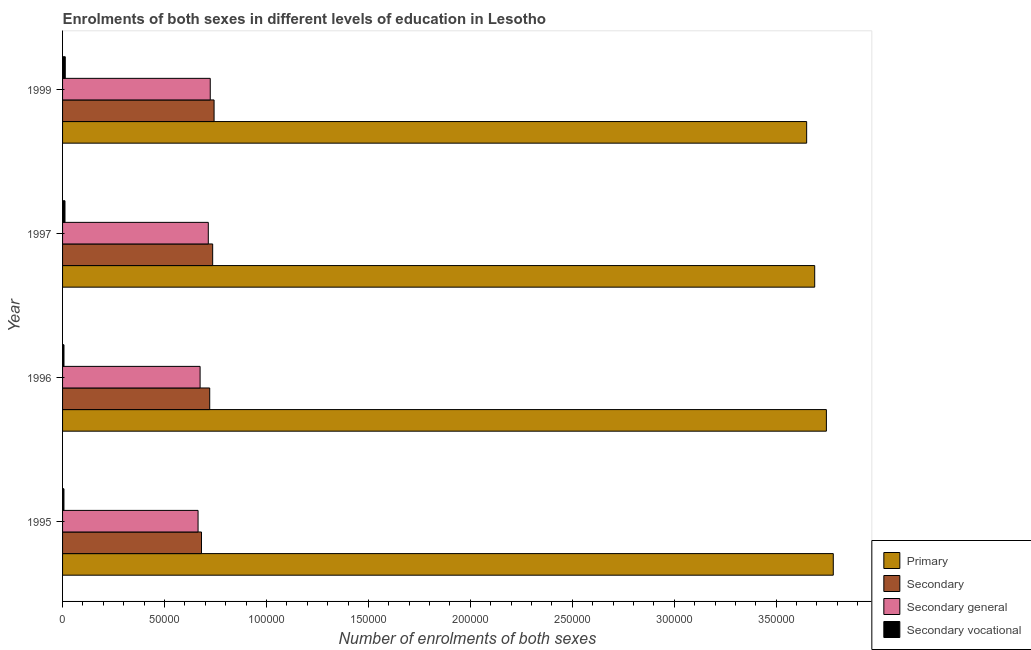How many groups of bars are there?
Give a very brief answer. 4. Are the number of bars per tick equal to the number of legend labels?
Offer a very short reply. Yes. How many bars are there on the 1st tick from the top?
Your answer should be compact. 4. How many bars are there on the 3rd tick from the bottom?
Ensure brevity in your answer.  4. What is the label of the 2nd group of bars from the top?
Offer a terse response. 1997. What is the number of enrolments in secondary general education in 1996?
Give a very brief answer. 6.75e+04. Across all years, what is the maximum number of enrolments in secondary general education?
Your answer should be very brief. 7.24e+04. Across all years, what is the minimum number of enrolments in secondary education?
Your answer should be compact. 6.81e+04. In which year was the number of enrolments in secondary education maximum?
Ensure brevity in your answer.  1999. What is the total number of enrolments in secondary general education in the graph?
Your response must be concise. 2.78e+05. What is the difference between the number of enrolments in secondary vocational education in 1996 and that in 1997?
Give a very brief answer. -488. What is the difference between the number of enrolments in secondary general education in 1995 and the number of enrolments in secondary vocational education in 1999?
Offer a terse response. 6.51e+04. What is the average number of enrolments in secondary general education per year?
Provide a short and direct response. 6.95e+04. In the year 1996, what is the difference between the number of enrolments in secondary vocational education and number of enrolments in primary education?
Provide a succinct answer. -3.74e+05. What is the difference between the highest and the second highest number of enrolments in secondary general education?
Give a very brief answer. 962. What is the difference between the highest and the lowest number of enrolments in secondary vocational education?
Provide a short and direct response. 643. In how many years, is the number of enrolments in primary education greater than the average number of enrolments in primary education taken over all years?
Give a very brief answer. 2. What does the 3rd bar from the top in 1995 represents?
Offer a very short reply. Secondary. What does the 1st bar from the bottom in 1996 represents?
Give a very brief answer. Primary. Is it the case that in every year, the sum of the number of enrolments in primary education and number of enrolments in secondary education is greater than the number of enrolments in secondary general education?
Offer a terse response. Yes. Are all the bars in the graph horizontal?
Your answer should be compact. Yes. How many years are there in the graph?
Ensure brevity in your answer.  4. Are the values on the major ticks of X-axis written in scientific E-notation?
Make the answer very short. No. Does the graph contain any zero values?
Provide a succinct answer. No. Where does the legend appear in the graph?
Your response must be concise. Bottom right. How many legend labels are there?
Make the answer very short. 4. How are the legend labels stacked?
Your response must be concise. Vertical. What is the title of the graph?
Your answer should be compact. Enrolments of both sexes in different levels of education in Lesotho. Does "Interest Payments" appear as one of the legend labels in the graph?
Ensure brevity in your answer.  No. What is the label or title of the X-axis?
Your response must be concise. Number of enrolments of both sexes. What is the label or title of the Y-axis?
Offer a very short reply. Year. What is the Number of enrolments of both sexes of Primary in 1995?
Give a very brief answer. 3.78e+05. What is the Number of enrolments of both sexes in Secondary in 1995?
Provide a short and direct response. 6.81e+04. What is the Number of enrolments of both sexes of Secondary general in 1995?
Offer a very short reply. 6.65e+04. What is the Number of enrolments of both sexes in Secondary vocational in 1995?
Provide a succinct answer. 678. What is the Number of enrolments of both sexes in Primary in 1996?
Provide a short and direct response. 3.75e+05. What is the Number of enrolments of both sexes in Secondary in 1996?
Your answer should be very brief. 7.22e+04. What is the Number of enrolments of both sexes in Secondary general in 1996?
Provide a succinct answer. 6.75e+04. What is the Number of enrolments of both sexes in Secondary vocational in 1996?
Offer a terse response. 695. What is the Number of enrolments of both sexes of Primary in 1997?
Ensure brevity in your answer.  3.69e+05. What is the Number of enrolments of both sexes in Secondary in 1997?
Offer a terse response. 7.36e+04. What is the Number of enrolments of both sexes in Secondary general in 1997?
Your answer should be very brief. 7.15e+04. What is the Number of enrolments of both sexes in Secondary vocational in 1997?
Ensure brevity in your answer.  1183. What is the Number of enrolments of both sexes of Primary in 1999?
Ensure brevity in your answer.  3.65e+05. What is the Number of enrolments of both sexes in Secondary in 1999?
Offer a terse response. 7.43e+04. What is the Number of enrolments of both sexes in Secondary general in 1999?
Give a very brief answer. 7.24e+04. What is the Number of enrolments of both sexes in Secondary vocational in 1999?
Your response must be concise. 1321. Across all years, what is the maximum Number of enrolments of both sexes in Primary?
Your answer should be very brief. 3.78e+05. Across all years, what is the maximum Number of enrolments of both sexes of Secondary?
Make the answer very short. 7.43e+04. Across all years, what is the maximum Number of enrolments of both sexes of Secondary general?
Your response must be concise. 7.24e+04. Across all years, what is the maximum Number of enrolments of both sexes in Secondary vocational?
Offer a terse response. 1321. Across all years, what is the minimum Number of enrolments of both sexes of Primary?
Keep it short and to the point. 3.65e+05. Across all years, what is the minimum Number of enrolments of both sexes of Secondary?
Offer a terse response. 6.81e+04. Across all years, what is the minimum Number of enrolments of both sexes of Secondary general?
Make the answer very short. 6.65e+04. Across all years, what is the minimum Number of enrolments of both sexes in Secondary vocational?
Offer a terse response. 678. What is the total Number of enrolments of both sexes of Primary in the graph?
Offer a very short reply. 1.49e+06. What is the total Number of enrolments of both sexes in Secondary in the graph?
Make the answer very short. 2.88e+05. What is the total Number of enrolments of both sexes in Secondary general in the graph?
Your answer should be very brief. 2.78e+05. What is the total Number of enrolments of both sexes of Secondary vocational in the graph?
Offer a very short reply. 3877. What is the difference between the Number of enrolments of both sexes of Primary in 1995 and that in 1996?
Make the answer very short. 3383. What is the difference between the Number of enrolments of both sexes in Secondary in 1995 and that in 1996?
Keep it short and to the point. -4038. What is the difference between the Number of enrolments of both sexes of Secondary general in 1995 and that in 1996?
Ensure brevity in your answer.  -1000. What is the difference between the Number of enrolments of both sexes of Secondary vocational in 1995 and that in 1996?
Your answer should be compact. -17. What is the difference between the Number of enrolments of both sexes in Primary in 1995 and that in 1997?
Keep it short and to the point. 9116. What is the difference between the Number of enrolments of both sexes of Secondary in 1995 and that in 1997?
Offer a terse response. -5488. What is the difference between the Number of enrolments of both sexes in Secondary general in 1995 and that in 1997?
Keep it short and to the point. -5021. What is the difference between the Number of enrolments of both sexes of Secondary vocational in 1995 and that in 1997?
Keep it short and to the point. -505. What is the difference between the Number of enrolments of both sexes of Primary in 1995 and that in 1999?
Your answer should be very brief. 1.31e+04. What is the difference between the Number of enrolments of both sexes in Secondary in 1995 and that in 1999?
Your answer should be compact. -6181. What is the difference between the Number of enrolments of both sexes in Secondary general in 1995 and that in 1999?
Give a very brief answer. -5983. What is the difference between the Number of enrolments of both sexes in Secondary vocational in 1995 and that in 1999?
Your answer should be compact. -643. What is the difference between the Number of enrolments of both sexes in Primary in 1996 and that in 1997?
Give a very brief answer. 5733. What is the difference between the Number of enrolments of both sexes of Secondary in 1996 and that in 1997?
Keep it short and to the point. -1450. What is the difference between the Number of enrolments of both sexes in Secondary general in 1996 and that in 1997?
Offer a very short reply. -4021. What is the difference between the Number of enrolments of both sexes of Secondary vocational in 1996 and that in 1997?
Provide a succinct answer. -488. What is the difference between the Number of enrolments of both sexes of Primary in 1996 and that in 1999?
Make the answer very short. 9677. What is the difference between the Number of enrolments of both sexes of Secondary in 1996 and that in 1999?
Offer a terse response. -2143. What is the difference between the Number of enrolments of both sexes of Secondary general in 1996 and that in 1999?
Provide a succinct answer. -4983. What is the difference between the Number of enrolments of both sexes of Secondary vocational in 1996 and that in 1999?
Your answer should be compact. -626. What is the difference between the Number of enrolments of both sexes of Primary in 1997 and that in 1999?
Offer a very short reply. 3944. What is the difference between the Number of enrolments of both sexes in Secondary in 1997 and that in 1999?
Your answer should be very brief. -693. What is the difference between the Number of enrolments of both sexes of Secondary general in 1997 and that in 1999?
Ensure brevity in your answer.  -962. What is the difference between the Number of enrolments of both sexes in Secondary vocational in 1997 and that in 1999?
Make the answer very short. -138. What is the difference between the Number of enrolments of both sexes in Primary in 1995 and the Number of enrolments of both sexes in Secondary in 1996?
Give a very brief answer. 3.06e+05. What is the difference between the Number of enrolments of both sexes of Primary in 1995 and the Number of enrolments of both sexes of Secondary general in 1996?
Your answer should be compact. 3.11e+05. What is the difference between the Number of enrolments of both sexes of Primary in 1995 and the Number of enrolments of both sexes of Secondary vocational in 1996?
Provide a short and direct response. 3.77e+05. What is the difference between the Number of enrolments of both sexes of Secondary in 1995 and the Number of enrolments of both sexes of Secondary general in 1996?
Offer a very short reply. 678. What is the difference between the Number of enrolments of both sexes in Secondary in 1995 and the Number of enrolments of both sexes in Secondary vocational in 1996?
Your response must be concise. 6.74e+04. What is the difference between the Number of enrolments of both sexes of Secondary general in 1995 and the Number of enrolments of both sexes of Secondary vocational in 1996?
Keep it short and to the point. 6.58e+04. What is the difference between the Number of enrolments of both sexes in Primary in 1995 and the Number of enrolments of both sexes in Secondary in 1997?
Provide a succinct answer. 3.04e+05. What is the difference between the Number of enrolments of both sexes of Primary in 1995 and the Number of enrolments of both sexes of Secondary general in 1997?
Your response must be concise. 3.07e+05. What is the difference between the Number of enrolments of both sexes of Primary in 1995 and the Number of enrolments of both sexes of Secondary vocational in 1997?
Keep it short and to the point. 3.77e+05. What is the difference between the Number of enrolments of both sexes in Secondary in 1995 and the Number of enrolments of both sexes in Secondary general in 1997?
Provide a succinct answer. -3343. What is the difference between the Number of enrolments of both sexes of Secondary in 1995 and the Number of enrolments of both sexes of Secondary vocational in 1997?
Your answer should be very brief. 6.69e+04. What is the difference between the Number of enrolments of both sexes in Secondary general in 1995 and the Number of enrolments of both sexes in Secondary vocational in 1997?
Make the answer very short. 6.53e+04. What is the difference between the Number of enrolments of both sexes of Primary in 1995 and the Number of enrolments of both sexes of Secondary in 1999?
Your response must be concise. 3.04e+05. What is the difference between the Number of enrolments of both sexes of Primary in 1995 and the Number of enrolments of both sexes of Secondary general in 1999?
Provide a short and direct response. 3.06e+05. What is the difference between the Number of enrolments of both sexes of Primary in 1995 and the Number of enrolments of both sexes of Secondary vocational in 1999?
Provide a succinct answer. 3.77e+05. What is the difference between the Number of enrolments of both sexes in Secondary in 1995 and the Number of enrolments of both sexes in Secondary general in 1999?
Your answer should be compact. -4305. What is the difference between the Number of enrolments of both sexes of Secondary in 1995 and the Number of enrolments of both sexes of Secondary vocational in 1999?
Give a very brief answer. 6.68e+04. What is the difference between the Number of enrolments of both sexes of Secondary general in 1995 and the Number of enrolments of both sexes of Secondary vocational in 1999?
Offer a very short reply. 6.51e+04. What is the difference between the Number of enrolments of both sexes in Primary in 1996 and the Number of enrolments of both sexes in Secondary in 1997?
Ensure brevity in your answer.  3.01e+05. What is the difference between the Number of enrolments of both sexes of Primary in 1996 and the Number of enrolments of both sexes of Secondary general in 1997?
Offer a very short reply. 3.03e+05. What is the difference between the Number of enrolments of both sexes of Primary in 1996 and the Number of enrolments of both sexes of Secondary vocational in 1997?
Your response must be concise. 3.73e+05. What is the difference between the Number of enrolments of both sexes of Secondary in 1996 and the Number of enrolments of both sexes of Secondary general in 1997?
Your answer should be very brief. 695. What is the difference between the Number of enrolments of both sexes of Secondary in 1996 and the Number of enrolments of both sexes of Secondary vocational in 1997?
Your response must be concise. 7.10e+04. What is the difference between the Number of enrolments of both sexes in Secondary general in 1996 and the Number of enrolments of both sexes in Secondary vocational in 1997?
Your answer should be compact. 6.63e+04. What is the difference between the Number of enrolments of both sexes of Primary in 1996 and the Number of enrolments of both sexes of Secondary in 1999?
Make the answer very short. 3.00e+05. What is the difference between the Number of enrolments of both sexes in Primary in 1996 and the Number of enrolments of both sexes in Secondary general in 1999?
Your answer should be compact. 3.02e+05. What is the difference between the Number of enrolments of both sexes in Primary in 1996 and the Number of enrolments of both sexes in Secondary vocational in 1999?
Your answer should be compact. 3.73e+05. What is the difference between the Number of enrolments of both sexes in Secondary in 1996 and the Number of enrolments of both sexes in Secondary general in 1999?
Ensure brevity in your answer.  -267. What is the difference between the Number of enrolments of both sexes of Secondary in 1996 and the Number of enrolments of both sexes of Secondary vocational in 1999?
Provide a short and direct response. 7.08e+04. What is the difference between the Number of enrolments of both sexes in Secondary general in 1996 and the Number of enrolments of both sexes in Secondary vocational in 1999?
Your answer should be compact. 6.61e+04. What is the difference between the Number of enrolments of both sexes in Primary in 1997 and the Number of enrolments of both sexes in Secondary in 1999?
Your answer should be compact. 2.95e+05. What is the difference between the Number of enrolments of both sexes in Primary in 1997 and the Number of enrolments of both sexes in Secondary general in 1999?
Provide a succinct answer. 2.96e+05. What is the difference between the Number of enrolments of both sexes of Primary in 1997 and the Number of enrolments of both sexes of Secondary vocational in 1999?
Your response must be concise. 3.68e+05. What is the difference between the Number of enrolments of both sexes of Secondary in 1997 and the Number of enrolments of both sexes of Secondary general in 1999?
Offer a very short reply. 1183. What is the difference between the Number of enrolments of both sexes in Secondary in 1997 and the Number of enrolments of both sexes in Secondary vocational in 1999?
Provide a short and direct response. 7.23e+04. What is the difference between the Number of enrolments of both sexes of Secondary general in 1997 and the Number of enrolments of both sexes of Secondary vocational in 1999?
Provide a succinct answer. 7.02e+04. What is the average Number of enrolments of both sexes in Primary per year?
Your response must be concise. 3.72e+05. What is the average Number of enrolments of both sexes of Secondary per year?
Your answer should be very brief. 7.21e+04. What is the average Number of enrolments of both sexes in Secondary general per year?
Offer a terse response. 6.95e+04. What is the average Number of enrolments of both sexes in Secondary vocational per year?
Provide a short and direct response. 969.25. In the year 1995, what is the difference between the Number of enrolments of both sexes in Primary and Number of enrolments of both sexes in Secondary?
Provide a short and direct response. 3.10e+05. In the year 1995, what is the difference between the Number of enrolments of both sexes in Primary and Number of enrolments of both sexes in Secondary general?
Your answer should be compact. 3.12e+05. In the year 1995, what is the difference between the Number of enrolments of both sexes in Primary and Number of enrolments of both sexes in Secondary vocational?
Offer a terse response. 3.77e+05. In the year 1995, what is the difference between the Number of enrolments of both sexes in Secondary and Number of enrolments of both sexes in Secondary general?
Make the answer very short. 1678. In the year 1995, what is the difference between the Number of enrolments of both sexes in Secondary and Number of enrolments of both sexes in Secondary vocational?
Ensure brevity in your answer.  6.75e+04. In the year 1995, what is the difference between the Number of enrolments of both sexes in Secondary general and Number of enrolments of both sexes in Secondary vocational?
Your answer should be compact. 6.58e+04. In the year 1996, what is the difference between the Number of enrolments of both sexes in Primary and Number of enrolments of both sexes in Secondary?
Ensure brevity in your answer.  3.02e+05. In the year 1996, what is the difference between the Number of enrolments of both sexes in Primary and Number of enrolments of both sexes in Secondary general?
Your answer should be very brief. 3.07e+05. In the year 1996, what is the difference between the Number of enrolments of both sexes in Primary and Number of enrolments of both sexes in Secondary vocational?
Offer a very short reply. 3.74e+05. In the year 1996, what is the difference between the Number of enrolments of both sexes in Secondary and Number of enrolments of both sexes in Secondary general?
Provide a short and direct response. 4716. In the year 1996, what is the difference between the Number of enrolments of both sexes in Secondary and Number of enrolments of both sexes in Secondary vocational?
Offer a terse response. 7.15e+04. In the year 1996, what is the difference between the Number of enrolments of both sexes in Secondary general and Number of enrolments of both sexes in Secondary vocational?
Offer a terse response. 6.68e+04. In the year 1997, what is the difference between the Number of enrolments of both sexes in Primary and Number of enrolments of both sexes in Secondary?
Make the answer very short. 2.95e+05. In the year 1997, what is the difference between the Number of enrolments of both sexes of Primary and Number of enrolments of both sexes of Secondary general?
Your response must be concise. 2.97e+05. In the year 1997, what is the difference between the Number of enrolments of both sexes in Primary and Number of enrolments of both sexes in Secondary vocational?
Your answer should be very brief. 3.68e+05. In the year 1997, what is the difference between the Number of enrolments of both sexes of Secondary and Number of enrolments of both sexes of Secondary general?
Offer a terse response. 2145. In the year 1997, what is the difference between the Number of enrolments of both sexes of Secondary and Number of enrolments of both sexes of Secondary vocational?
Provide a succinct answer. 7.24e+04. In the year 1997, what is the difference between the Number of enrolments of both sexes in Secondary general and Number of enrolments of both sexes in Secondary vocational?
Keep it short and to the point. 7.03e+04. In the year 1999, what is the difference between the Number of enrolments of both sexes in Primary and Number of enrolments of both sexes in Secondary?
Offer a terse response. 2.91e+05. In the year 1999, what is the difference between the Number of enrolments of both sexes in Primary and Number of enrolments of both sexes in Secondary general?
Offer a very short reply. 2.93e+05. In the year 1999, what is the difference between the Number of enrolments of both sexes of Primary and Number of enrolments of both sexes of Secondary vocational?
Offer a terse response. 3.64e+05. In the year 1999, what is the difference between the Number of enrolments of both sexes of Secondary and Number of enrolments of both sexes of Secondary general?
Offer a very short reply. 1876. In the year 1999, what is the difference between the Number of enrolments of both sexes in Secondary and Number of enrolments of both sexes in Secondary vocational?
Provide a succinct answer. 7.30e+04. In the year 1999, what is the difference between the Number of enrolments of both sexes in Secondary general and Number of enrolments of both sexes in Secondary vocational?
Your answer should be compact. 7.11e+04. What is the ratio of the Number of enrolments of both sexes of Primary in 1995 to that in 1996?
Keep it short and to the point. 1.01. What is the ratio of the Number of enrolments of both sexes in Secondary in 1995 to that in 1996?
Your answer should be compact. 0.94. What is the ratio of the Number of enrolments of both sexes of Secondary general in 1995 to that in 1996?
Offer a very short reply. 0.99. What is the ratio of the Number of enrolments of both sexes of Secondary vocational in 1995 to that in 1996?
Provide a succinct answer. 0.98. What is the ratio of the Number of enrolments of both sexes in Primary in 1995 to that in 1997?
Ensure brevity in your answer.  1.02. What is the ratio of the Number of enrolments of both sexes in Secondary in 1995 to that in 1997?
Ensure brevity in your answer.  0.93. What is the ratio of the Number of enrolments of both sexes of Secondary general in 1995 to that in 1997?
Keep it short and to the point. 0.93. What is the ratio of the Number of enrolments of both sexes of Secondary vocational in 1995 to that in 1997?
Provide a succinct answer. 0.57. What is the ratio of the Number of enrolments of both sexes of Primary in 1995 to that in 1999?
Offer a very short reply. 1.04. What is the ratio of the Number of enrolments of both sexes in Secondary in 1995 to that in 1999?
Offer a very short reply. 0.92. What is the ratio of the Number of enrolments of both sexes of Secondary general in 1995 to that in 1999?
Offer a terse response. 0.92. What is the ratio of the Number of enrolments of both sexes of Secondary vocational in 1995 to that in 1999?
Provide a succinct answer. 0.51. What is the ratio of the Number of enrolments of both sexes of Primary in 1996 to that in 1997?
Ensure brevity in your answer.  1.02. What is the ratio of the Number of enrolments of both sexes of Secondary in 1996 to that in 1997?
Offer a very short reply. 0.98. What is the ratio of the Number of enrolments of both sexes in Secondary general in 1996 to that in 1997?
Provide a short and direct response. 0.94. What is the ratio of the Number of enrolments of both sexes in Secondary vocational in 1996 to that in 1997?
Ensure brevity in your answer.  0.59. What is the ratio of the Number of enrolments of both sexes in Primary in 1996 to that in 1999?
Your answer should be compact. 1.03. What is the ratio of the Number of enrolments of both sexes in Secondary in 1996 to that in 1999?
Provide a succinct answer. 0.97. What is the ratio of the Number of enrolments of both sexes of Secondary general in 1996 to that in 1999?
Your answer should be very brief. 0.93. What is the ratio of the Number of enrolments of both sexes in Secondary vocational in 1996 to that in 1999?
Provide a succinct answer. 0.53. What is the ratio of the Number of enrolments of both sexes in Primary in 1997 to that in 1999?
Your response must be concise. 1.01. What is the ratio of the Number of enrolments of both sexes in Secondary in 1997 to that in 1999?
Give a very brief answer. 0.99. What is the ratio of the Number of enrolments of both sexes of Secondary general in 1997 to that in 1999?
Keep it short and to the point. 0.99. What is the ratio of the Number of enrolments of both sexes in Secondary vocational in 1997 to that in 1999?
Your answer should be compact. 0.9. What is the difference between the highest and the second highest Number of enrolments of both sexes of Primary?
Your answer should be compact. 3383. What is the difference between the highest and the second highest Number of enrolments of both sexes in Secondary?
Offer a terse response. 693. What is the difference between the highest and the second highest Number of enrolments of both sexes of Secondary general?
Offer a very short reply. 962. What is the difference between the highest and the second highest Number of enrolments of both sexes of Secondary vocational?
Make the answer very short. 138. What is the difference between the highest and the lowest Number of enrolments of both sexes of Primary?
Your answer should be very brief. 1.31e+04. What is the difference between the highest and the lowest Number of enrolments of both sexes in Secondary?
Keep it short and to the point. 6181. What is the difference between the highest and the lowest Number of enrolments of both sexes of Secondary general?
Provide a short and direct response. 5983. What is the difference between the highest and the lowest Number of enrolments of both sexes of Secondary vocational?
Provide a short and direct response. 643. 